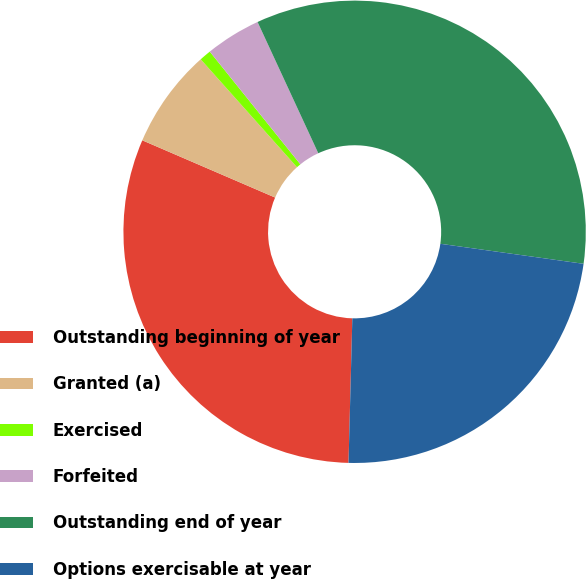Convert chart to OTSL. <chart><loc_0><loc_0><loc_500><loc_500><pie_chart><fcel>Outstanding beginning of year<fcel>Granted (a)<fcel>Exercised<fcel>Forfeited<fcel>Outstanding end of year<fcel>Options exercisable at year<nl><fcel>31.06%<fcel>6.93%<fcel>0.82%<fcel>3.88%<fcel>34.11%<fcel>23.21%<nl></chart> 